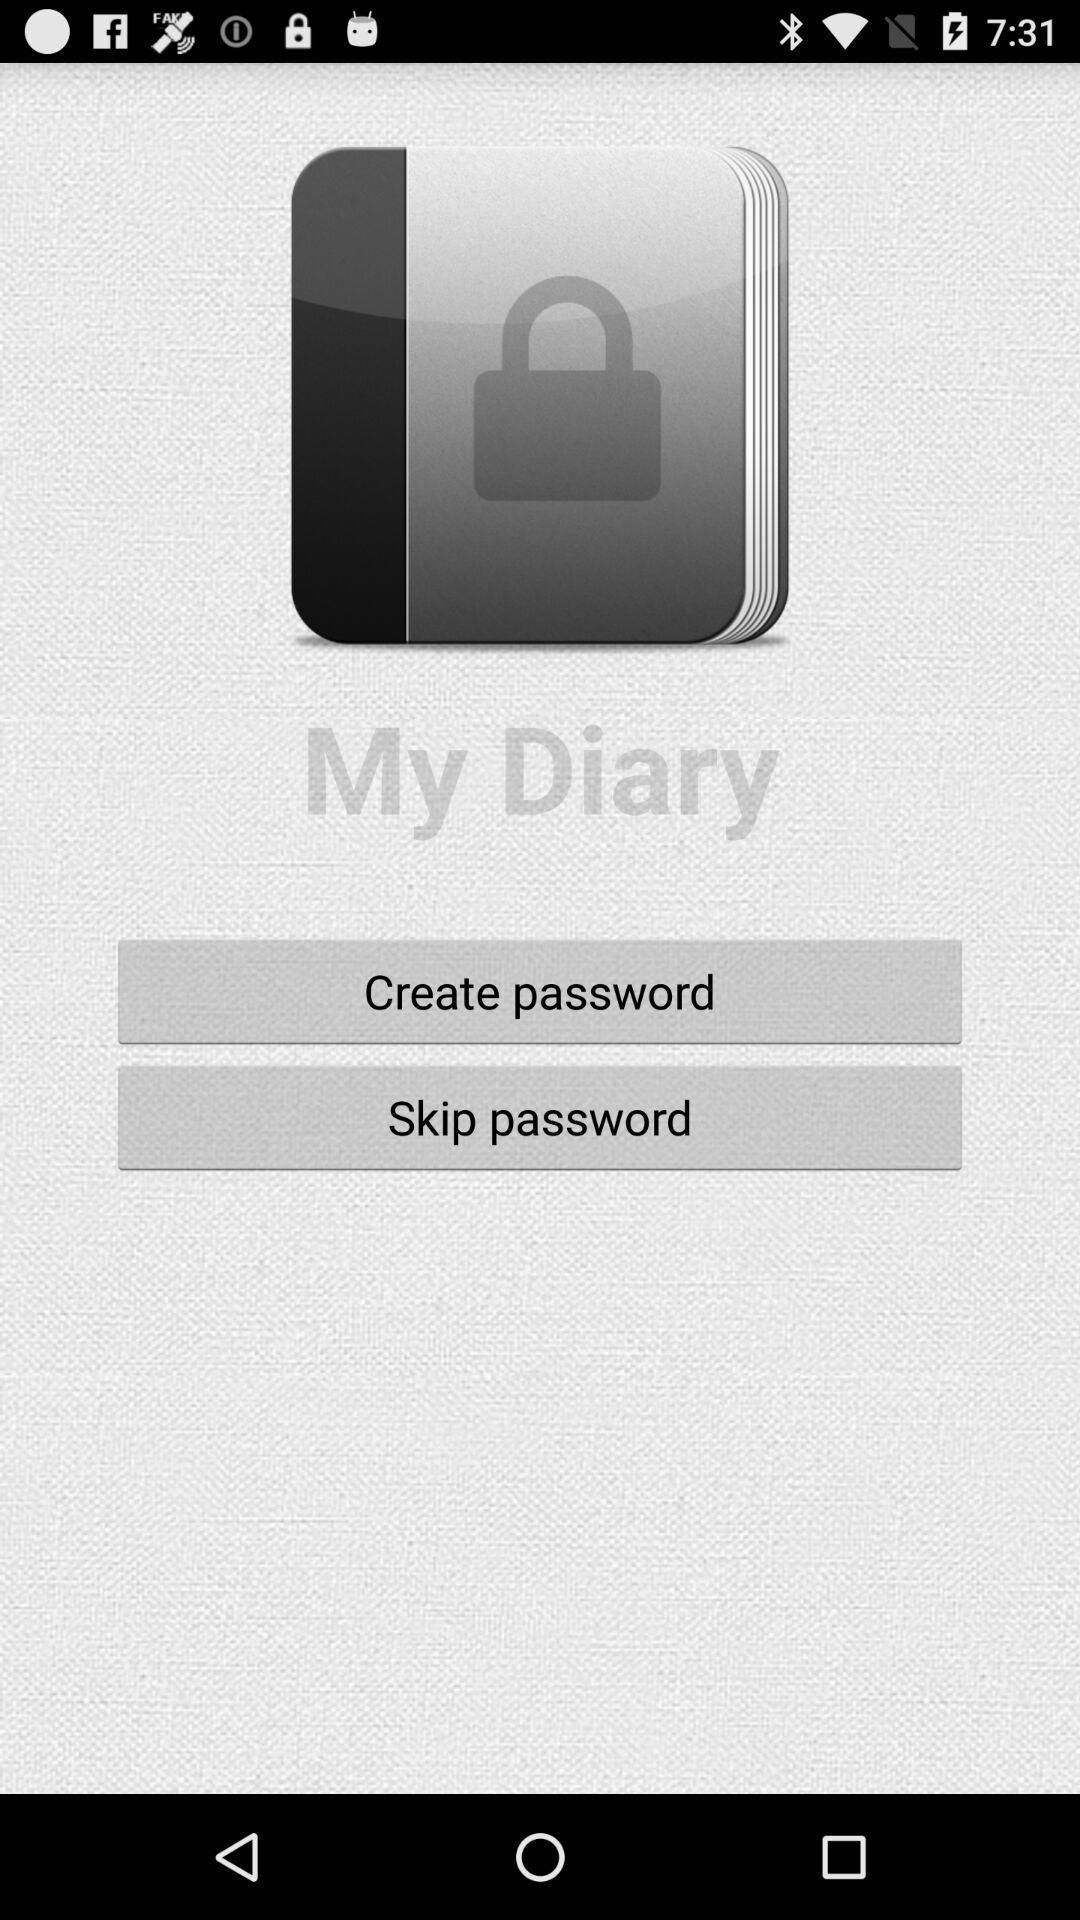Provide a detailed account of this screenshot. Screen displaying to create or skip password. 